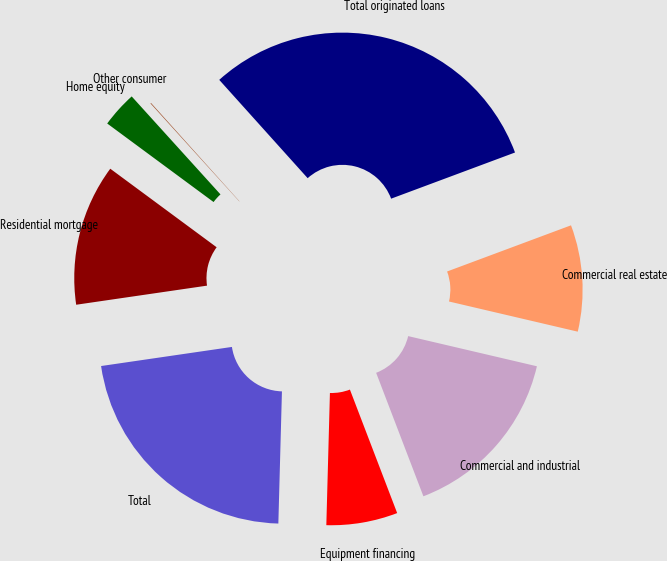Convert chart. <chart><loc_0><loc_0><loc_500><loc_500><pie_chart><fcel>Commercial real estate<fcel>Commercial and industrial<fcel>Equipment financing<fcel>Total<fcel>Residential mortgage<fcel>Home equity<fcel>Other consumer<fcel>Total originated loans<nl><fcel>9.34%<fcel>15.52%<fcel>6.25%<fcel>22.26%<fcel>12.43%<fcel>3.16%<fcel>0.06%<fcel>30.98%<nl></chart> 